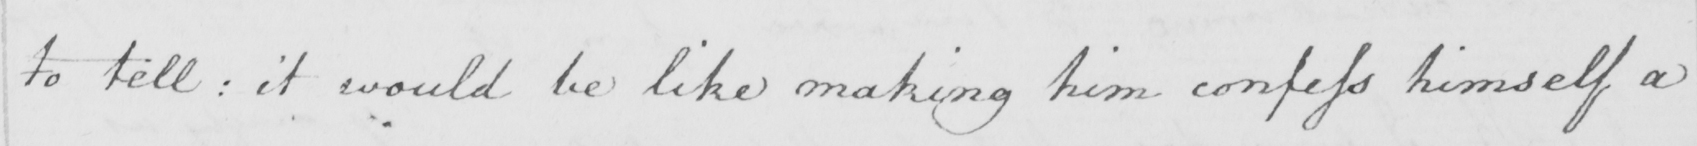Please provide the text content of this handwritten line. to tell :  it would be like making him confess himself a 